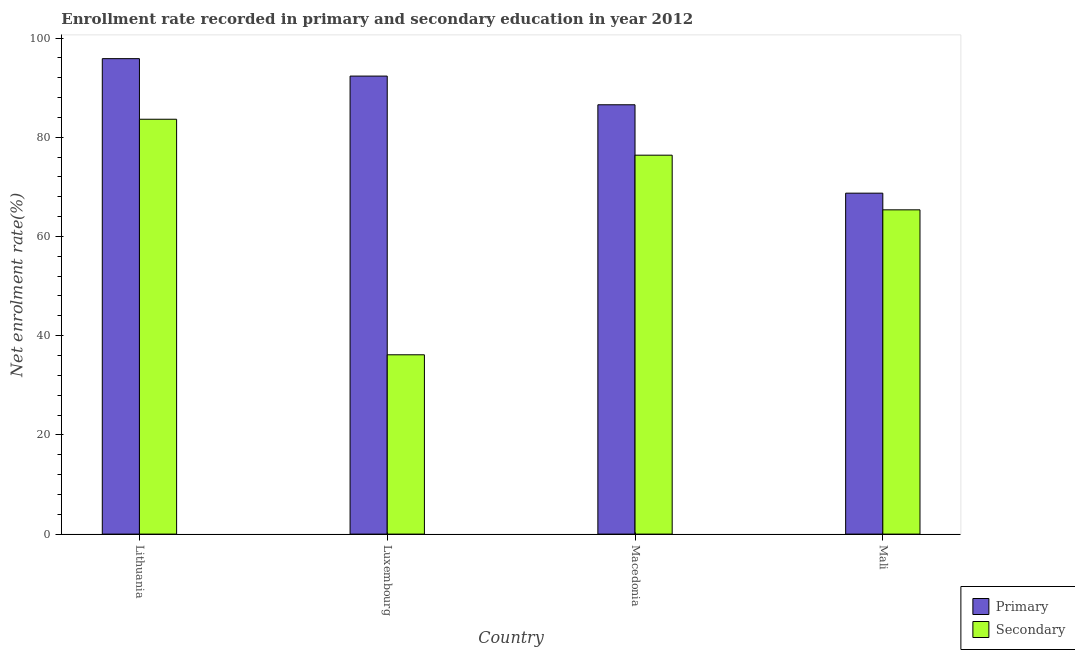How many different coloured bars are there?
Your response must be concise. 2. How many groups of bars are there?
Offer a terse response. 4. Are the number of bars on each tick of the X-axis equal?
Offer a very short reply. Yes. How many bars are there on the 1st tick from the left?
Keep it short and to the point. 2. How many bars are there on the 2nd tick from the right?
Make the answer very short. 2. What is the label of the 1st group of bars from the left?
Ensure brevity in your answer.  Lithuania. What is the enrollment rate in primary education in Luxembourg?
Offer a very short reply. 92.33. Across all countries, what is the maximum enrollment rate in secondary education?
Make the answer very short. 83.63. Across all countries, what is the minimum enrollment rate in secondary education?
Give a very brief answer. 36.15. In which country was the enrollment rate in secondary education maximum?
Offer a very short reply. Lithuania. In which country was the enrollment rate in secondary education minimum?
Give a very brief answer. Luxembourg. What is the total enrollment rate in primary education in the graph?
Your response must be concise. 343.45. What is the difference between the enrollment rate in primary education in Lithuania and that in Luxembourg?
Make the answer very short. 3.51. What is the difference between the enrollment rate in primary education in Macedonia and the enrollment rate in secondary education in Mali?
Provide a succinct answer. 21.18. What is the average enrollment rate in primary education per country?
Your answer should be very brief. 85.86. What is the difference between the enrollment rate in primary education and enrollment rate in secondary education in Luxembourg?
Provide a succinct answer. 56.18. What is the ratio of the enrollment rate in secondary education in Luxembourg to that in Mali?
Make the answer very short. 0.55. Is the difference between the enrollment rate in primary education in Lithuania and Luxembourg greater than the difference between the enrollment rate in secondary education in Lithuania and Luxembourg?
Your response must be concise. No. What is the difference between the highest and the second highest enrollment rate in secondary education?
Keep it short and to the point. 7.24. What is the difference between the highest and the lowest enrollment rate in secondary education?
Offer a very short reply. 47.48. Is the sum of the enrollment rate in secondary education in Lithuania and Macedonia greater than the maximum enrollment rate in primary education across all countries?
Your answer should be very brief. Yes. What does the 2nd bar from the left in Lithuania represents?
Offer a terse response. Secondary. What does the 2nd bar from the right in Lithuania represents?
Make the answer very short. Primary. How many bars are there?
Offer a terse response. 8. Where does the legend appear in the graph?
Your answer should be very brief. Bottom right. What is the title of the graph?
Ensure brevity in your answer.  Enrollment rate recorded in primary and secondary education in year 2012. What is the label or title of the Y-axis?
Give a very brief answer. Net enrolment rate(%). What is the Net enrolment rate(%) in Primary in Lithuania?
Keep it short and to the point. 95.85. What is the Net enrolment rate(%) of Secondary in Lithuania?
Your answer should be compact. 83.63. What is the Net enrolment rate(%) in Primary in Luxembourg?
Offer a very short reply. 92.33. What is the Net enrolment rate(%) of Secondary in Luxembourg?
Offer a very short reply. 36.15. What is the Net enrolment rate(%) in Primary in Macedonia?
Offer a terse response. 86.55. What is the Net enrolment rate(%) of Secondary in Macedonia?
Ensure brevity in your answer.  76.39. What is the Net enrolment rate(%) of Primary in Mali?
Offer a very short reply. 68.73. What is the Net enrolment rate(%) in Secondary in Mali?
Your response must be concise. 65.37. Across all countries, what is the maximum Net enrolment rate(%) of Primary?
Your answer should be compact. 95.85. Across all countries, what is the maximum Net enrolment rate(%) of Secondary?
Give a very brief answer. 83.63. Across all countries, what is the minimum Net enrolment rate(%) of Primary?
Make the answer very short. 68.73. Across all countries, what is the minimum Net enrolment rate(%) in Secondary?
Provide a succinct answer. 36.15. What is the total Net enrolment rate(%) of Primary in the graph?
Ensure brevity in your answer.  343.45. What is the total Net enrolment rate(%) in Secondary in the graph?
Your answer should be compact. 261.53. What is the difference between the Net enrolment rate(%) of Primary in Lithuania and that in Luxembourg?
Offer a terse response. 3.52. What is the difference between the Net enrolment rate(%) of Secondary in Lithuania and that in Luxembourg?
Your response must be concise. 47.48. What is the difference between the Net enrolment rate(%) of Primary in Lithuania and that in Macedonia?
Provide a short and direct response. 9.3. What is the difference between the Net enrolment rate(%) of Secondary in Lithuania and that in Macedonia?
Your answer should be compact. 7.24. What is the difference between the Net enrolment rate(%) in Primary in Lithuania and that in Mali?
Your response must be concise. 27.12. What is the difference between the Net enrolment rate(%) of Secondary in Lithuania and that in Mali?
Ensure brevity in your answer.  18.26. What is the difference between the Net enrolment rate(%) of Primary in Luxembourg and that in Macedonia?
Keep it short and to the point. 5.78. What is the difference between the Net enrolment rate(%) of Secondary in Luxembourg and that in Macedonia?
Your answer should be very brief. -40.24. What is the difference between the Net enrolment rate(%) of Primary in Luxembourg and that in Mali?
Your answer should be compact. 23.6. What is the difference between the Net enrolment rate(%) of Secondary in Luxembourg and that in Mali?
Provide a short and direct response. -29.22. What is the difference between the Net enrolment rate(%) in Primary in Macedonia and that in Mali?
Your answer should be very brief. 17.82. What is the difference between the Net enrolment rate(%) in Secondary in Macedonia and that in Mali?
Ensure brevity in your answer.  11.02. What is the difference between the Net enrolment rate(%) of Primary in Lithuania and the Net enrolment rate(%) of Secondary in Luxembourg?
Your response must be concise. 59.7. What is the difference between the Net enrolment rate(%) of Primary in Lithuania and the Net enrolment rate(%) of Secondary in Macedonia?
Make the answer very short. 19.46. What is the difference between the Net enrolment rate(%) in Primary in Lithuania and the Net enrolment rate(%) in Secondary in Mali?
Your answer should be very brief. 30.48. What is the difference between the Net enrolment rate(%) of Primary in Luxembourg and the Net enrolment rate(%) of Secondary in Macedonia?
Give a very brief answer. 15.94. What is the difference between the Net enrolment rate(%) in Primary in Luxembourg and the Net enrolment rate(%) in Secondary in Mali?
Your answer should be very brief. 26.96. What is the difference between the Net enrolment rate(%) of Primary in Macedonia and the Net enrolment rate(%) of Secondary in Mali?
Provide a succinct answer. 21.18. What is the average Net enrolment rate(%) of Primary per country?
Make the answer very short. 85.86. What is the average Net enrolment rate(%) in Secondary per country?
Give a very brief answer. 65.38. What is the difference between the Net enrolment rate(%) in Primary and Net enrolment rate(%) in Secondary in Lithuania?
Your answer should be very brief. 12.21. What is the difference between the Net enrolment rate(%) of Primary and Net enrolment rate(%) of Secondary in Luxembourg?
Your answer should be very brief. 56.18. What is the difference between the Net enrolment rate(%) of Primary and Net enrolment rate(%) of Secondary in Macedonia?
Ensure brevity in your answer.  10.16. What is the difference between the Net enrolment rate(%) in Primary and Net enrolment rate(%) in Secondary in Mali?
Give a very brief answer. 3.36. What is the ratio of the Net enrolment rate(%) in Primary in Lithuania to that in Luxembourg?
Offer a very short reply. 1.04. What is the ratio of the Net enrolment rate(%) in Secondary in Lithuania to that in Luxembourg?
Ensure brevity in your answer.  2.31. What is the ratio of the Net enrolment rate(%) in Primary in Lithuania to that in Macedonia?
Ensure brevity in your answer.  1.11. What is the ratio of the Net enrolment rate(%) of Secondary in Lithuania to that in Macedonia?
Provide a succinct answer. 1.09. What is the ratio of the Net enrolment rate(%) of Primary in Lithuania to that in Mali?
Your answer should be very brief. 1.39. What is the ratio of the Net enrolment rate(%) of Secondary in Lithuania to that in Mali?
Keep it short and to the point. 1.28. What is the ratio of the Net enrolment rate(%) of Primary in Luxembourg to that in Macedonia?
Make the answer very short. 1.07. What is the ratio of the Net enrolment rate(%) in Secondary in Luxembourg to that in Macedonia?
Offer a very short reply. 0.47. What is the ratio of the Net enrolment rate(%) of Primary in Luxembourg to that in Mali?
Provide a short and direct response. 1.34. What is the ratio of the Net enrolment rate(%) of Secondary in Luxembourg to that in Mali?
Keep it short and to the point. 0.55. What is the ratio of the Net enrolment rate(%) in Primary in Macedonia to that in Mali?
Provide a succinct answer. 1.26. What is the ratio of the Net enrolment rate(%) in Secondary in Macedonia to that in Mali?
Provide a short and direct response. 1.17. What is the difference between the highest and the second highest Net enrolment rate(%) in Primary?
Offer a terse response. 3.52. What is the difference between the highest and the second highest Net enrolment rate(%) in Secondary?
Your answer should be very brief. 7.24. What is the difference between the highest and the lowest Net enrolment rate(%) of Primary?
Ensure brevity in your answer.  27.12. What is the difference between the highest and the lowest Net enrolment rate(%) in Secondary?
Ensure brevity in your answer.  47.48. 